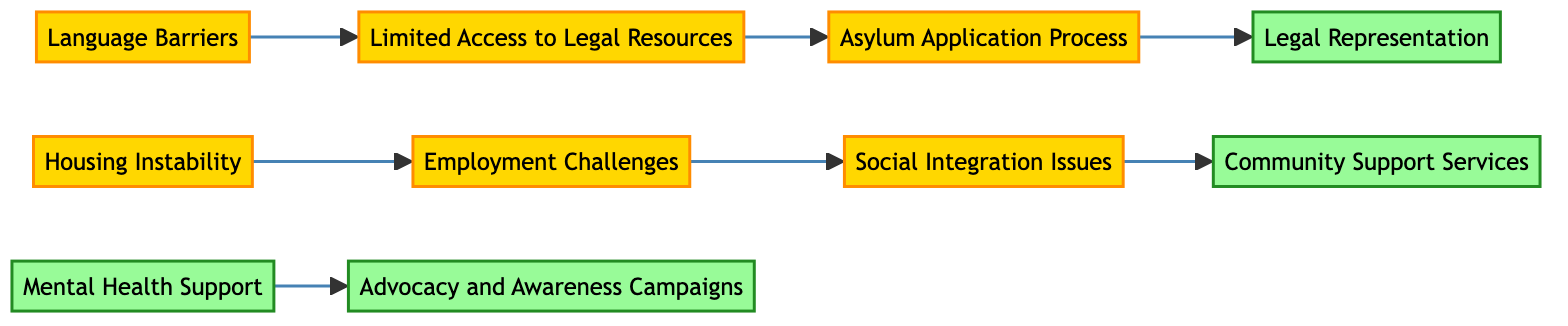What is the total number of nodes in the diagram? The diagram consists of 10 nodes representing different challenges and solutions related to refugees.
Answer: 10 What is the relationship between "Language Barriers" and "Limited Access to Legal Resources"? There is a direct edge from "Language Barriers" to "Limited Access to Legal Resources," indicating that language barriers can hinder access to legal resources.
Answer: Limited Access to Legal Resources Which challenge directly leads to "Legal Representation"? The "Asylum Application Process" directly connects to "Legal Representation," indicating that navigating the asylum application is crucial for obtaining legal representation.
Answer: Asylum Application Process How many solutions are represented in the diagram? The diagram includes 4 solutions, which are "Legal Representation," "Community Support Services," "Mental Health Support," and "Advocacy and Awareness Campaigns."
Answer: 4 What challenge is linked to "Employment Challenges"? "Housing Instability" is the challenge that leads to "Employment Challenges," indicating that unstable housing can impact employment opportunities.
Answer: Housing Instability Which two challenges are connected via "Social Integration Issues"? "Employment Challenges" connects to "Social Integration Issues," which means challenges in employment can affect the social integration of refugees.
Answer: Employment Challenges What is the only challenge that connects to "Advocacy and Awareness Campaigns"? "Mental Health Support" has a direct connection to "Advocacy and Awareness Campaigns," implying that mental health advocacy is essential for awareness campaigns.
Answer: Mental Health Support How many edges are present in the diagram? The diagram consists of 7 edges, each representing a directed relationship between challenges and solutions.
Answer: 7 Which challenge indirectly influences "Community Support Services"? "Social Integration Issues" leads to "Community Support Services," indicating that challenges in social integration can affect the community support available to refugees.
Answer: Social Integration Issues Which node has no incoming edges? "Language Barriers" has no incoming edges, indicating that it is the starting point for the connections in the diagram.
Answer: Language Barriers 